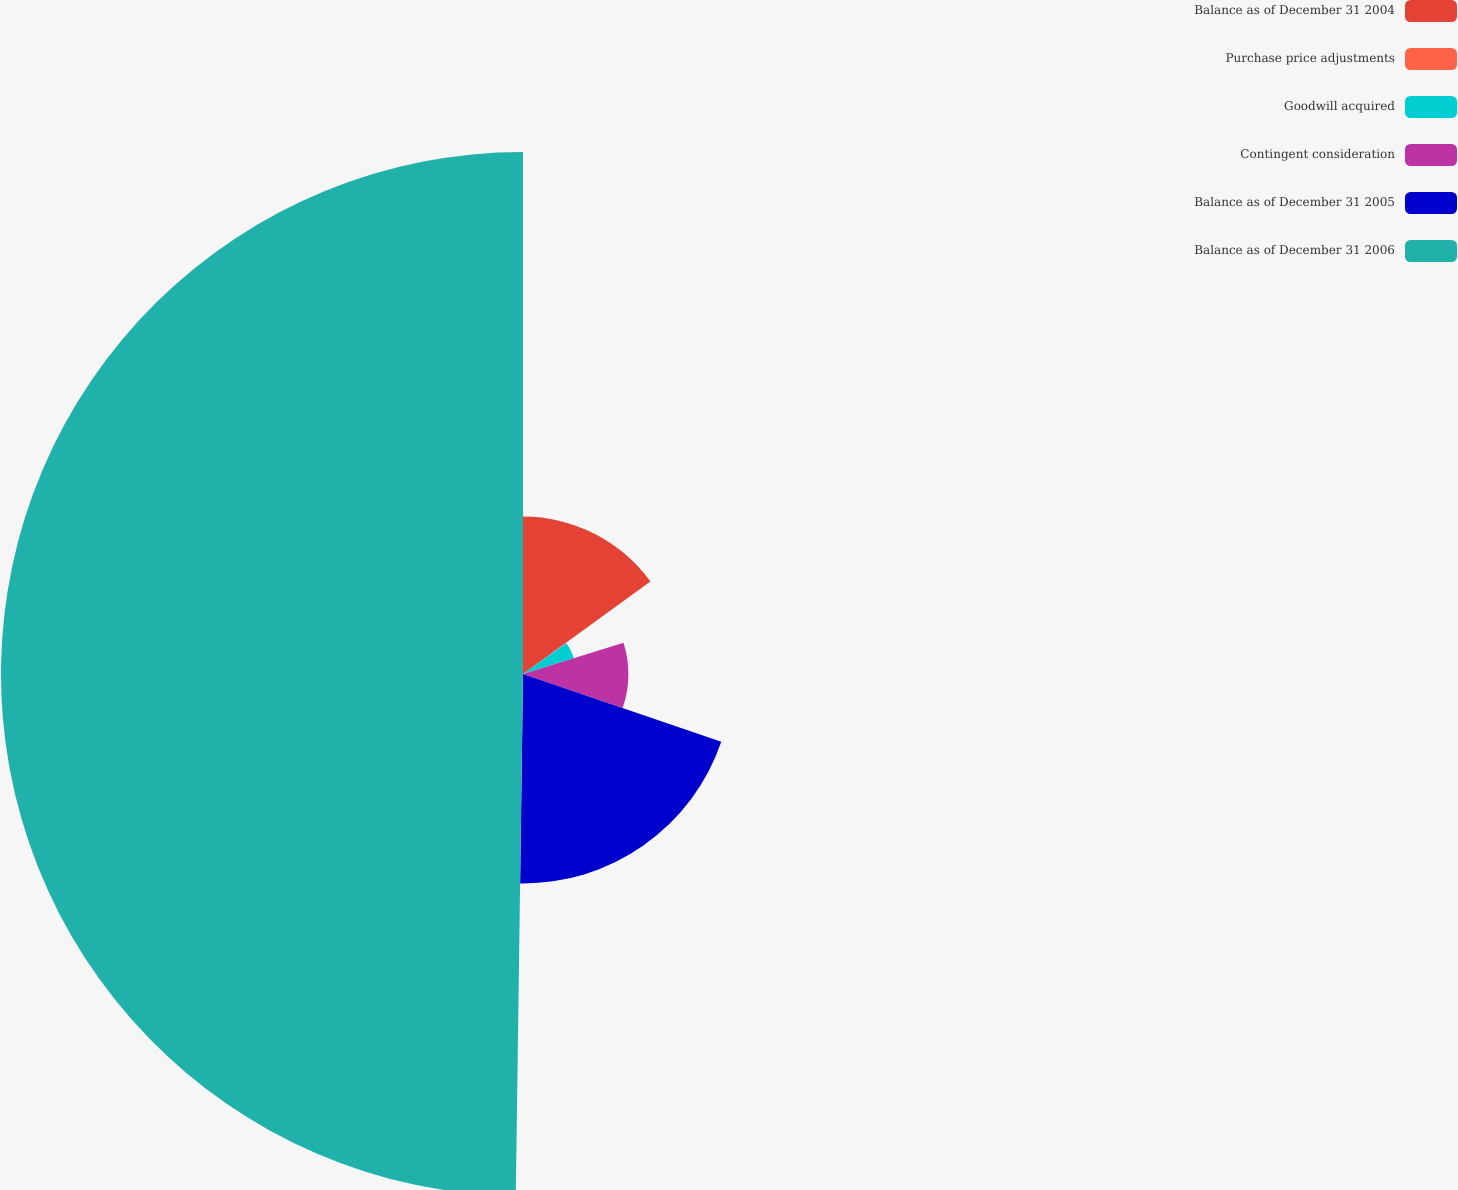Convert chart to OTSL. <chart><loc_0><loc_0><loc_500><loc_500><pie_chart><fcel>Balance as of December 31 2004<fcel>Purchase price adjustments<fcel>Goodwill acquired<fcel>Contingent consideration<fcel>Balance as of December 31 2005<fcel>Balance as of December 31 2006<nl><fcel>15.01%<fcel>0.11%<fcel>5.08%<fcel>10.04%<fcel>19.98%<fcel>49.78%<nl></chart> 